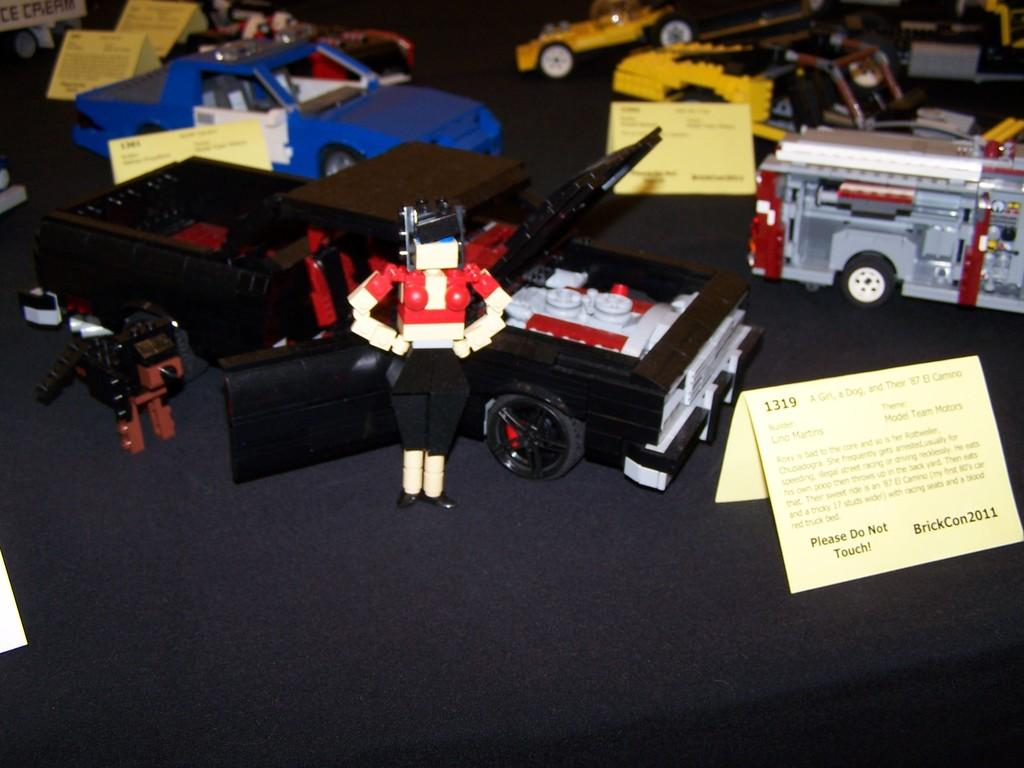<image>
Describe the image concisely. A display with a sign stating Please Do Not Touch! 